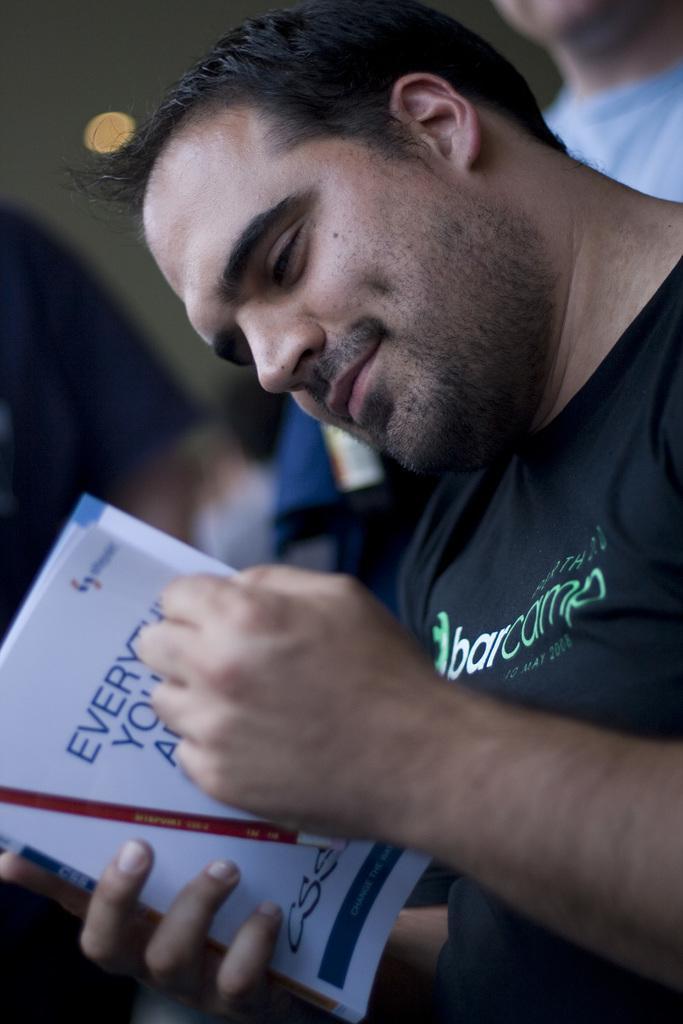How would you summarize this image in a sentence or two? This image consists of a man wearing black T-shirt is reading a book. In the background, we can see a wall and another man. 